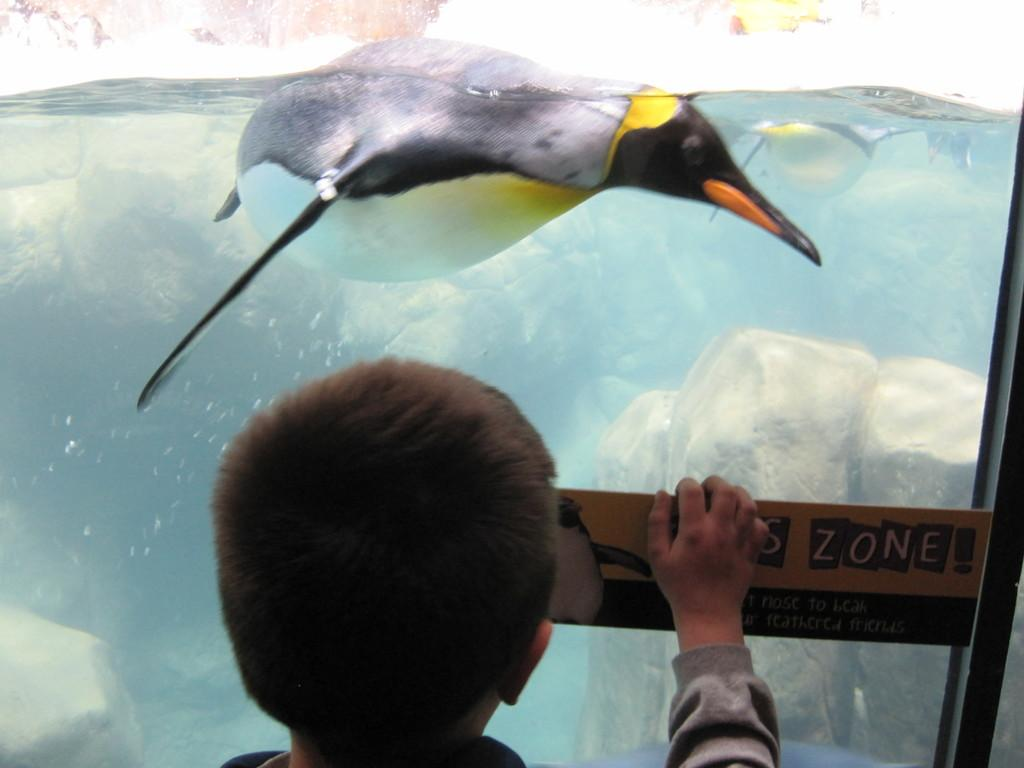What is the main object in the image? There is an aquarium in the image. What is inside the aquarium? There is water inside the aquarium. What type of animals can be seen in the aquarium? There are penguins in the aquarium. Who is present near the aquarium? There is a boy standing in front of the aquarium. What type of paste is being used by the penguins in the image? There is no paste present in the image; it features an aquarium with penguins and a boy standing nearby. 